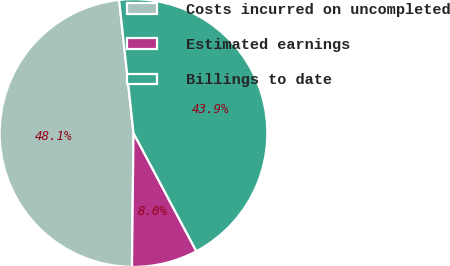Convert chart to OTSL. <chart><loc_0><loc_0><loc_500><loc_500><pie_chart><fcel>Costs incurred on uncompleted<fcel>Estimated earnings<fcel>Billings to date<nl><fcel>48.11%<fcel>7.96%<fcel>43.93%<nl></chart> 